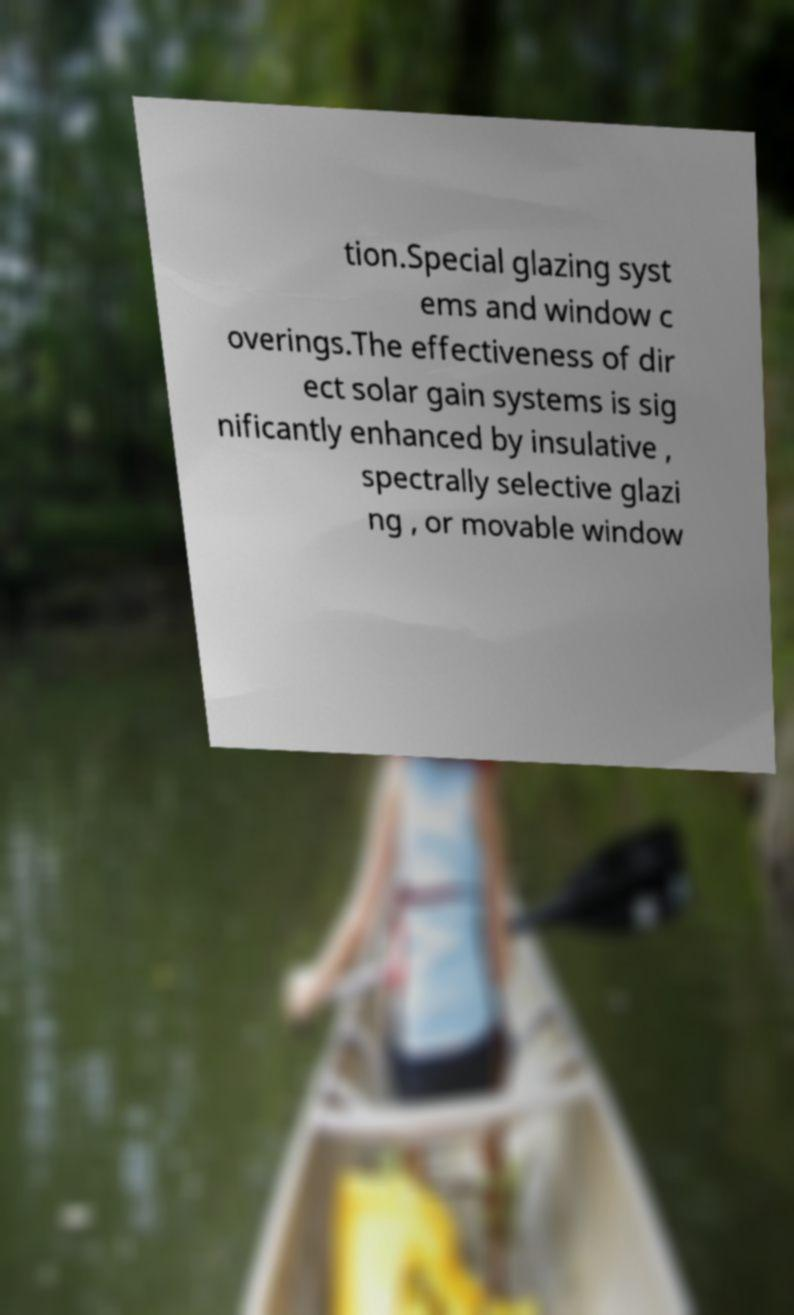I need the written content from this picture converted into text. Can you do that? tion.Special glazing syst ems and window c overings.The effectiveness of dir ect solar gain systems is sig nificantly enhanced by insulative , spectrally selective glazi ng , or movable window 